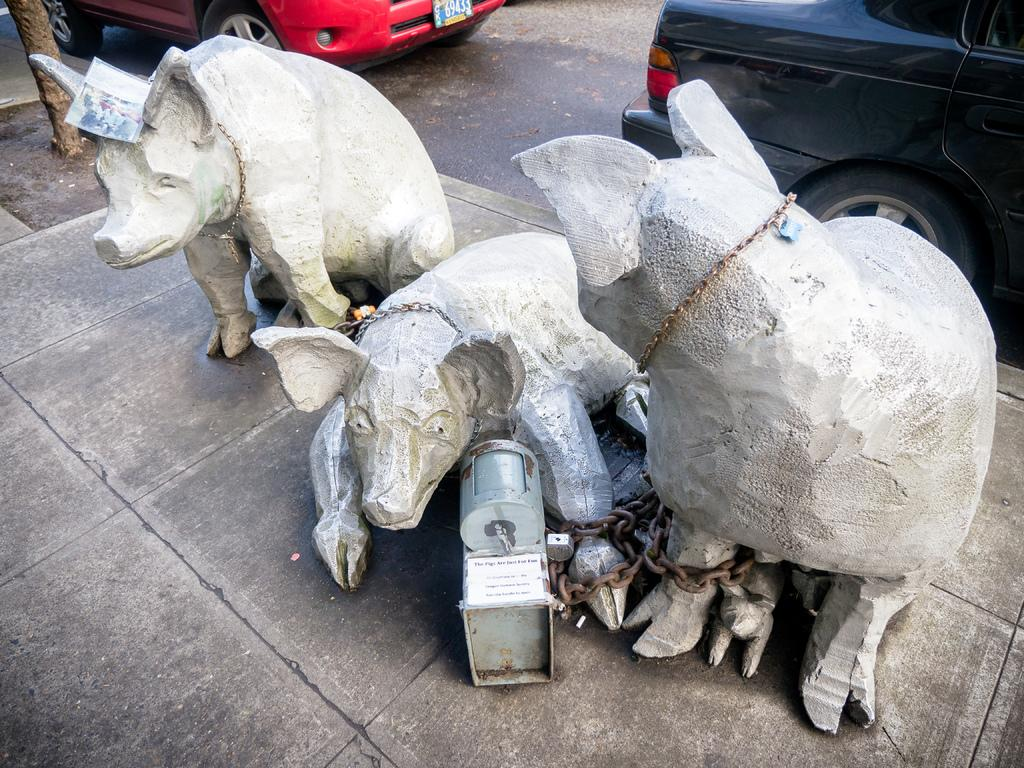What type of path is visible in the image? There is a sidewalk in the image. What can be found on the sidewalk? There are statues on the sidewalk, shaped like animals. What else is visible in the image besides the sidewalk? There is a road visible in the image, as well as a tree. What is happening on the road? There are vehicles on the road. How many bushes are present in the image? There are no bushes mentioned or visible in the image. What shape is the square in the image? There is no square present in the image; the image does not depict a square, and the conversation does not mention any shapes. 